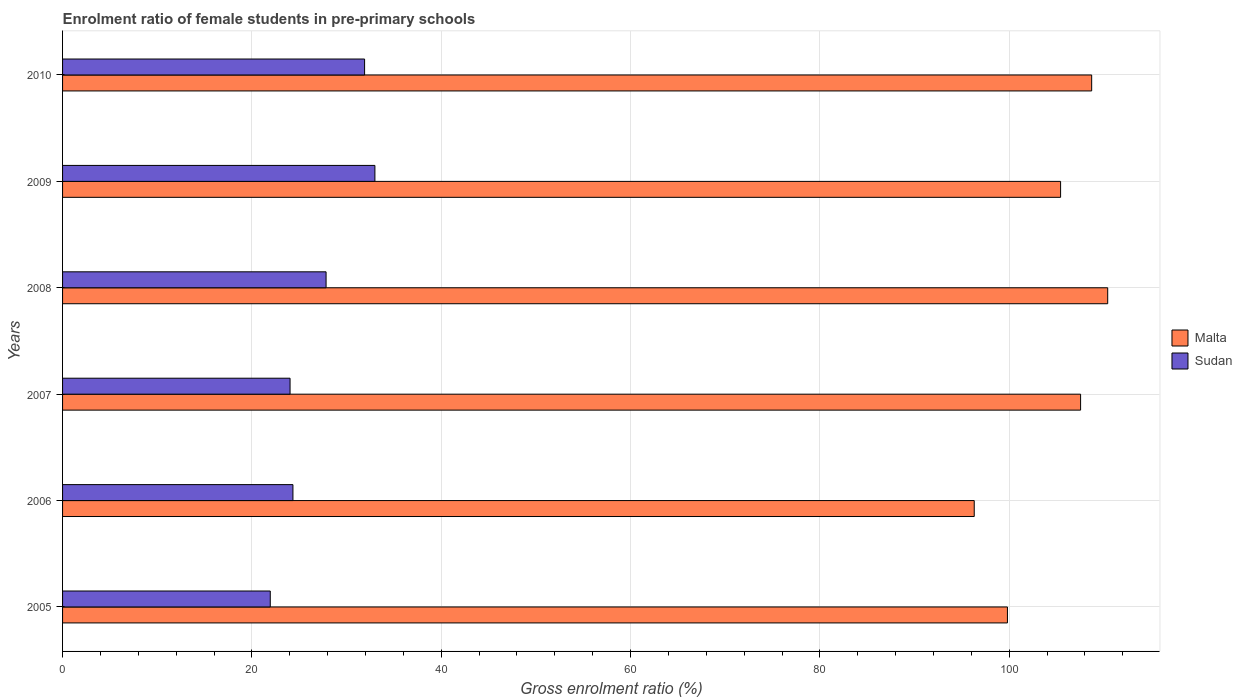How many different coloured bars are there?
Offer a very short reply. 2. Are the number of bars per tick equal to the number of legend labels?
Offer a terse response. Yes. How many bars are there on the 1st tick from the bottom?
Your answer should be compact. 2. What is the label of the 5th group of bars from the top?
Give a very brief answer. 2006. What is the enrolment ratio of female students in pre-primary schools in Malta in 2006?
Ensure brevity in your answer.  96.31. Across all years, what is the maximum enrolment ratio of female students in pre-primary schools in Malta?
Keep it short and to the point. 110.4. Across all years, what is the minimum enrolment ratio of female students in pre-primary schools in Malta?
Offer a terse response. 96.31. What is the total enrolment ratio of female students in pre-primary schools in Sudan in the graph?
Provide a succinct answer. 163.04. What is the difference between the enrolment ratio of female students in pre-primary schools in Malta in 2005 and that in 2010?
Your response must be concise. -8.9. What is the difference between the enrolment ratio of female students in pre-primary schools in Sudan in 2005 and the enrolment ratio of female students in pre-primary schools in Malta in 2008?
Provide a succinct answer. -88.46. What is the average enrolment ratio of female students in pre-primary schools in Malta per year?
Your response must be concise. 104.7. In the year 2009, what is the difference between the enrolment ratio of female students in pre-primary schools in Malta and enrolment ratio of female students in pre-primary schools in Sudan?
Make the answer very short. 72.43. In how many years, is the enrolment ratio of female students in pre-primary schools in Malta greater than 4 %?
Give a very brief answer. 6. What is the ratio of the enrolment ratio of female students in pre-primary schools in Sudan in 2008 to that in 2010?
Ensure brevity in your answer.  0.87. Is the enrolment ratio of female students in pre-primary schools in Malta in 2006 less than that in 2007?
Your response must be concise. Yes. What is the difference between the highest and the second highest enrolment ratio of female students in pre-primary schools in Malta?
Make the answer very short. 1.69. What is the difference between the highest and the lowest enrolment ratio of female students in pre-primary schools in Sudan?
Keep it short and to the point. 11.05. In how many years, is the enrolment ratio of female students in pre-primary schools in Malta greater than the average enrolment ratio of female students in pre-primary schools in Malta taken over all years?
Provide a short and direct response. 4. Is the sum of the enrolment ratio of female students in pre-primary schools in Sudan in 2005 and 2009 greater than the maximum enrolment ratio of female students in pre-primary schools in Malta across all years?
Provide a short and direct response. No. What does the 1st bar from the top in 2010 represents?
Provide a succinct answer. Sudan. What does the 1st bar from the bottom in 2008 represents?
Offer a very short reply. Malta. How many bars are there?
Make the answer very short. 12. Are all the bars in the graph horizontal?
Make the answer very short. Yes. How many years are there in the graph?
Give a very brief answer. 6. What is the difference between two consecutive major ticks on the X-axis?
Your answer should be very brief. 20. Does the graph contain grids?
Provide a succinct answer. Yes. How many legend labels are there?
Provide a short and direct response. 2. How are the legend labels stacked?
Offer a very short reply. Vertical. What is the title of the graph?
Give a very brief answer. Enrolment ratio of female students in pre-primary schools. What is the label or title of the X-axis?
Provide a short and direct response. Gross enrolment ratio (%). What is the Gross enrolment ratio (%) in Malta in 2005?
Your response must be concise. 99.81. What is the Gross enrolment ratio (%) in Sudan in 2005?
Provide a short and direct response. 21.94. What is the Gross enrolment ratio (%) of Malta in 2006?
Ensure brevity in your answer.  96.31. What is the Gross enrolment ratio (%) of Sudan in 2006?
Your answer should be compact. 24.33. What is the Gross enrolment ratio (%) in Malta in 2007?
Your answer should be very brief. 107.54. What is the Gross enrolment ratio (%) of Sudan in 2007?
Provide a succinct answer. 24.03. What is the Gross enrolment ratio (%) of Malta in 2008?
Provide a succinct answer. 110.4. What is the Gross enrolment ratio (%) in Sudan in 2008?
Give a very brief answer. 27.84. What is the Gross enrolment ratio (%) of Malta in 2009?
Give a very brief answer. 105.43. What is the Gross enrolment ratio (%) in Sudan in 2009?
Provide a short and direct response. 32.99. What is the Gross enrolment ratio (%) in Malta in 2010?
Offer a terse response. 108.71. What is the Gross enrolment ratio (%) in Sudan in 2010?
Your answer should be compact. 31.9. Across all years, what is the maximum Gross enrolment ratio (%) of Malta?
Offer a very short reply. 110.4. Across all years, what is the maximum Gross enrolment ratio (%) of Sudan?
Your answer should be compact. 32.99. Across all years, what is the minimum Gross enrolment ratio (%) of Malta?
Offer a terse response. 96.31. Across all years, what is the minimum Gross enrolment ratio (%) of Sudan?
Provide a succinct answer. 21.94. What is the total Gross enrolment ratio (%) in Malta in the graph?
Provide a succinct answer. 628.2. What is the total Gross enrolment ratio (%) of Sudan in the graph?
Ensure brevity in your answer.  163.04. What is the difference between the Gross enrolment ratio (%) in Malta in 2005 and that in 2006?
Make the answer very short. 3.51. What is the difference between the Gross enrolment ratio (%) of Sudan in 2005 and that in 2006?
Offer a terse response. -2.39. What is the difference between the Gross enrolment ratio (%) of Malta in 2005 and that in 2007?
Your answer should be very brief. -7.73. What is the difference between the Gross enrolment ratio (%) of Sudan in 2005 and that in 2007?
Your answer should be compact. -2.09. What is the difference between the Gross enrolment ratio (%) in Malta in 2005 and that in 2008?
Make the answer very short. -10.59. What is the difference between the Gross enrolment ratio (%) of Sudan in 2005 and that in 2008?
Your answer should be very brief. -5.9. What is the difference between the Gross enrolment ratio (%) of Malta in 2005 and that in 2009?
Provide a succinct answer. -5.62. What is the difference between the Gross enrolment ratio (%) of Sudan in 2005 and that in 2009?
Keep it short and to the point. -11.05. What is the difference between the Gross enrolment ratio (%) of Malta in 2005 and that in 2010?
Provide a short and direct response. -8.9. What is the difference between the Gross enrolment ratio (%) in Sudan in 2005 and that in 2010?
Give a very brief answer. -9.96. What is the difference between the Gross enrolment ratio (%) in Malta in 2006 and that in 2007?
Provide a short and direct response. -11.24. What is the difference between the Gross enrolment ratio (%) of Sudan in 2006 and that in 2007?
Your response must be concise. 0.3. What is the difference between the Gross enrolment ratio (%) of Malta in 2006 and that in 2008?
Your answer should be compact. -14.1. What is the difference between the Gross enrolment ratio (%) in Sudan in 2006 and that in 2008?
Provide a succinct answer. -3.5. What is the difference between the Gross enrolment ratio (%) in Malta in 2006 and that in 2009?
Keep it short and to the point. -9.12. What is the difference between the Gross enrolment ratio (%) of Sudan in 2006 and that in 2009?
Your answer should be compact. -8.66. What is the difference between the Gross enrolment ratio (%) in Malta in 2006 and that in 2010?
Offer a terse response. -12.41. What is the difference between the Gross enrolment ratio (%) in Sudan in 2006 and that in 2010?
Ensure brevity in your answer.  -7.57. What is the difference between the Gross enrolment ratio (%) in Malta in 2007 and that in 2008?
Give a very brief answer. -2.86. What is the difference between the Gross enrolment ratio (%) of Sudan in 2007 and that in 2008?
Keep it short and to the point. -3.8. What is the difference between the Gross enrolment ratio (%) of Malta in 2007 and that in 2009?
Keep it short and to the point. 2.11. What is the difference between the Gross enrolment ratio (%) of Sudan in 2007 and that in 2009?
Provide a short and direct response. -8.96. What is the difference between the Gross enrolment ratio (%) in Malta in 2007 and that in 2010?
Provide a succinct answer. -1.17. What is the difference between the Gross enrolment ratio (%) in Sudan in 2007 and that in 2010?
Your answer should be very brief. -7.87. What is the difference between the Gross enrolment ratio (%) of Malta in 2008 and that in 2009?
Your response must be concise. 4.98. What is the difference between the Gross enrolment ratio (%) in Sudan in 2008 and that in 2009?
Your answer should be very brief. -5.16. What is the difference between the Gross enrolment ratio (%) in Malta in 2008 and that in 2010?
Your answer should be compact. 1.69. What is the difference between the Gross enrolment ratio (%) in Sudan in 2008 and that in 2010?
Ensure brevity in your answer.  -4.07. What is the difference between the Gross enrolment ratio (%) in Malta in 2009 and that in 2010?
Ensure brevity in your answer.  -3.28. What is the difference between the Gross enrolment ratio (%) of Sudan in 2009 and that in 2010?
Make the answer very short. 1.09. What is the difference between the Gross enrolment ratio (%) in Malta in 2005 and the Gross enrolment ratio (%) in Sudan in 2006?
Make the answer very short. 75.48. What is the difference between the Gross enrolment ratio (%) of Malta in 2005 and the Gross enrolment ratio (%) of Sudan in 2007?
Ensure brevity in your answer.  75.78. What is the difference between the Gross enrolment ratio (%) in Malta in 2005 and the Gross enrolment ratio (%) in Sudan in 2008?
Make the answer very short. 71.98. What is the difference between the Gross enrolment ratio (%) in Malta in 2005 and the Gross enrolment ratio (%) in Sudan in 2009?
Ensure brevity in your answer.  66.82. What is the difference between the Gross enrolment ratio (%) of Malta in 2005 and the Gross enrolment ratio (%) of Sudan in 2010?
Your response must be concise. 67.91. What is the difference between the Gross enrolment ratio (%) of Malta in 2006 and the Gross enrolment ratio (%) of Sudan in 2007?
Keep it short and to the point. 72.27. What is the difference between the Gross enrolment ratio (%) of Malta in 2006 and the Gross enrolment ratio (%) of Sudan in 2008?
Ensure brevity in your answer.  68.47. What is the difference between the Gross enrolment ratio (%) of Malta in 2006 and the Gross enrolment ratio (%) of Sudan in 2009?
Your answer should be very brief. 63.31. What is the difference between the Gross enrolment ratio (%) in Malta in 2006 and the Gross enrolment ratio (%) in Sudan in 2010?
Offer a terse response. 64.4. What is the difference between the Gross enrolment ratio (%) of Malta in 2007 and the Gross enrolment ratio (%) of Sudan in 2008?
Your response must be concise. 79.7. What is the difference between the Gross enrolment ratio (%) in Malta in 2007 and the Gross enrolment ratio (%) in Sudan in 2009?
Your answer should be very brief. 74.55. What is the difference between the Gross enrolment ratio (%) of Malta in 2007 and the Gross enrolment ratio (%) of Sudan in 2010?
Provide a succinct answer. 75.64. What is the difference between the Gross enrolment ratio (%) in Malta in 2008 and the Gross enrolment ratio (%) in Sudan in 2009?
Ensure brevity in your answer.  77.41. What is the difference between the Gross enrolment ratio (%) of Malta in 2008 and the Gross enrolment ratio (%) of Sudan in 2010?
Give a very brief answer. 78.5. What is the difference between the Gross enrolment ratio (%) of Malta in 2009 and the Gross enrolment ratio (%) of Sudan in 2010?
Keep it short and to the point. 73.52. What is the average Gross enrolment ratio (%) in Malta per year?
Keep it short and to the point. 104.7. What is the average Gross enrolment ratio (%) of Sudan per year?
Your response must be concise. 27.17. In the year 2005, what is the difference between the Gross enrolment ratio (%) of Malta and Gross enrolment ratio (%) of Sudan?
Give a very brief answer. 77.87. In the year 2006, what is the difference between the Gross enrolment ratio (%) of Malta and Gross enrolment ratio (%) of Sudan?
Offer a very short reply. 71.97. In the year 2007, what is the difference between the Gross enrolment ratio (%) of Malta and Gross enrolment ratio (%) of Sudan?
Provide a succinct answer. 83.51. In the year 2008, what is the difference between the Gross enrolment ratio (%) of Malta and Gross enrolment ratio (%) of Sudan?
Your response must be concise. 82.57. In the year 2009, what is the difference between the Gross enrolment ratio (%) of Malta and Gross enrolment ratio (%) of Sudan?
Keep it short and to the point. 72.43. In the year 2010, what is the difference between the Gross enrolment ratio (%) in Malta and Gross enrolment ratio (%) in Sudan?
Offer a very short reply. 76.81. What is the ratio of the Gross enrolment ratio (%) in Malta in 2005 to that in 2006?
Your response must be concise. 1.04. What is the ratio of the Gross enrolment ratio (%) in Sudan in 2005 to that in 2006?
Make the answer very short. 0.9. What is the ratio of the Gross enrolment ratio (%) of Malta in 2005 to that in 2007?
Provide a short and direct response. 0.93. What is the ratio of the Gross enrolment ratio (%) of Malta in 2005 to that in 2008?
Offer a very short reply. 0.9. What is the ratio of the Gross enrolment ratio (%) of Sudan in 2005 to that in 2008?
Offer a terse response. 0.79. What is the ratio of the Gross enrolment ratio (%) in Malta in 2005 to that in 2009?
Provide a succinct answer. 0.95. What is the ratio of the Gross enrolment ratio (%) in Sudan in 2005 to that in 2009?
Your response must be concise. 0.67. What is the ratio of the Gross enrolment ratio (%) of Malta in 2005 to that in 2010?
Your response must be concise. 0.92. What is the ratio of the Gross enrolment ratio (%) of Sudan in 2005 to that in 2010?
Keep it short and to the point. 0.69. What is the ratio of the Gross enrolment ratio (%) in Malta in 2006 to that in 2007?
Keep it short and to the point. 0.9. What is the ratio of the Gross enrolment ratio (%) in Sudan in 2006 to that in 2007?
Keep it short and to the point. 1.01. What is the ratio of the Gross enrolment ratio (%) of Malta in 2006 to that in 2008?
Offer a very short reply. 0.87. What is the ratio of the Gross enrolment ratio (%) of Sudan in 2006 to that in 2008?
Your answer should be very brief. 0.87. What is the ratio of the Gross enrolment ratio (%) in Malta in 2006 to that in 2009?
Your response must be concise. 0.91. What is the ratio of the Gross enrolment ratio (%) in Sudan in 2006 to that in 2009?
Provide a succinct answer. 0.74. What is the ratio of the Gross enrolment ratio (%) of Malta in 2006 to that in 2010?
Offer a very short reply. 0.89. What is the ratio of the Gross enrolment ratio (%) of Sudan in 2006 to that in 2010?
Your answer should be very brief. 0.76. What is the ratio of the Gross enrolment ratio (%) in Malta in 2007 to that in 2008?
Keep it short and to the point. 0.97. What is the ratio of the Gross enrolment ratio (%) in Sudan in 2007 to that in 2008?
Keep it short and to the point. 0.86. What is the ratio of the Gross enrolment ratio (%) of Malta in 2007 to that in 2009?
Make the answer very short. 1.02. What is the ratio of the Gross enrolment ratio (%) in Sudan in 2007 to that in 2009?
Ensure brevity in your answer.  0.73. What is the ratio of the Gross enrolment ratio (%) in Malta in 2007 to that in 2010?
Give a very brief answer. 0.99. What is the ratio of the Gross enrolment ratio (%) of Sudan in 2007 to that in 2010?
Your answer should be compact. 0.75. What is the ratio of the Gross enrolment ratio (%) of Malta in 2008 to that in 2009?
Your answer should be very brief. 1.05. What is the ratio of the Gross enrolment ratio (%) in Sudan in 2008 to that in 2009?
Ensure brevity in your answer.  0.84. What is the ratio of the Gross enrolment ratio (%) of Malta in 2008 to that in 2010?
Keep it short and to the point. 1.02. What is the ratio of the Gross enrolment ratio (%) in Sudan in 2008 to that in 2010?
Your answer should be very brief. 0.87. What is the ratio of the Gross enrolment ratio (%) in Malta in 2009 to that in 2010?
Give a very brief answer. 0.97. What is the ratio of the Gross enrolment ratio (%) of Sudan in 2009 to that in 2010?
Offer a terse response. 1.03. What is the difference between the highest and the second highest Gross enrolment ratio (%) in Malta?
Give a very brief answer. 1.69. What is the difference between the highest and the second highest Gross enrolment ratio (%) in Sudan?
Provide a succinct answer. 1.09. What is the difference between the highest and the lowest Gross enrolment ratio (%) in Malta?
Keep it short and to the point. 14.1. What is the difference between the highest and the lowest Gross enrolment ratio (%) in Sudan?
Offer a very short reply. 11.05. 